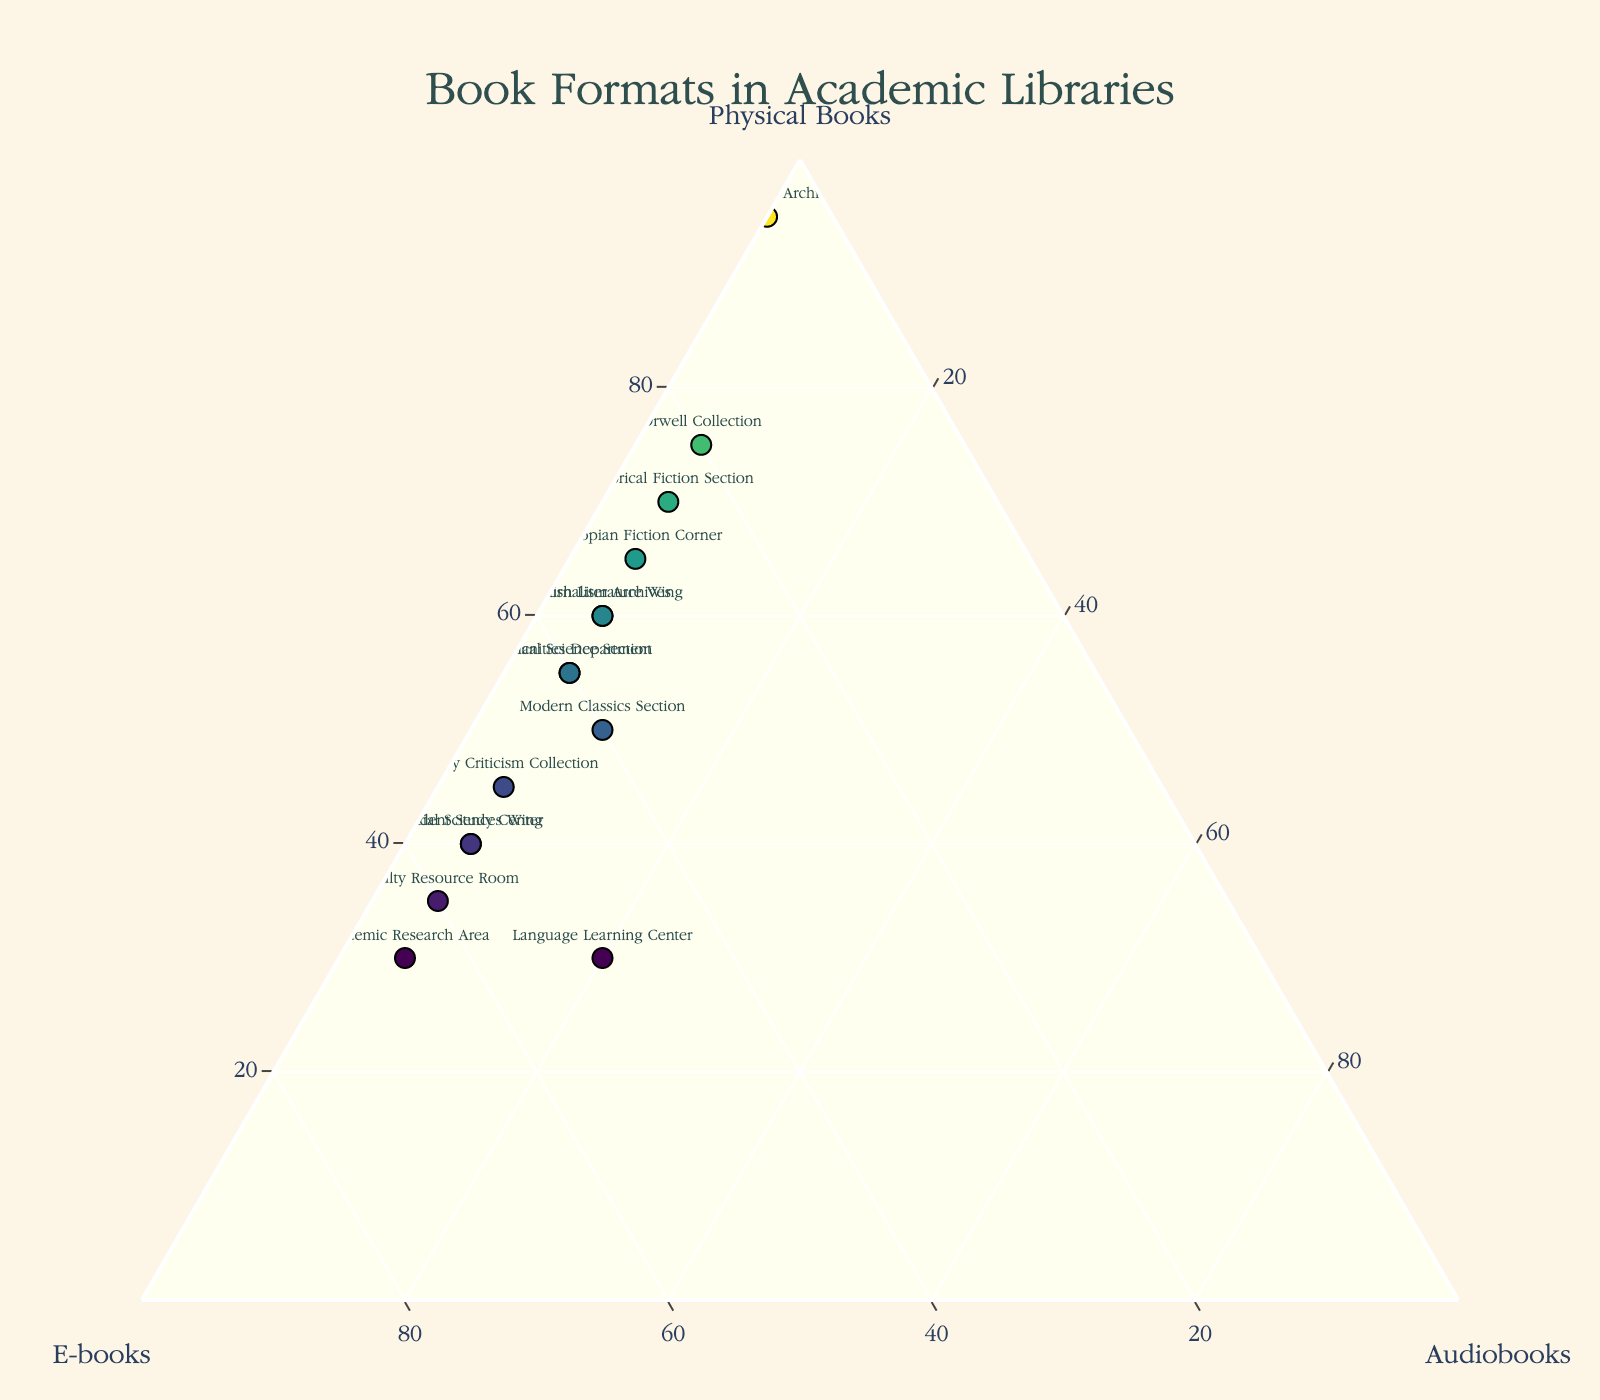How many libraries have at least 60% physical books? In the ternary plot, locate the data points where the 'Physical Books' value is 60 or higher. These points represent the libraries with at least 60% physical books.
Answer: 6 What is the sum of percentages for e-books and audiobooks in the Orwell Collection? Find the Orwell Collection on the plot and add its e-books (20) and audiobooks (5) percentages.
Answer: 25 Which library has the highest percentage of physical books? Identify the data point positioned closest to the 'Physical Books' vertex. Here, the 'Rare Books Archive' has 95% physical books.
Answer: Rare Books Archive How does the Humanities Department compare to the Social Sciences Wing in terms of e-books and audiobooks combined? Locate the two libraries on the plot and add the e-books and audiobooks percentages: Humanities Department (40 + 5 = 45) and Social Sciences Wing (55 + 5 = 60). The Social Sciences Wing has a higher combined percentage.
Answer: Social Sciences Wing Which libraries have an equal distribution of e-books and physical books? Find data points along the line where e-books and physical books percentages are the same. The parity means the e-books and physical books values should be visually equal or nearly equal. No libraries have exactly equal values in this dataset.
Answer: None Are there any libraries that have 0% audiobooks? Identify data points situated directly on the 'Physical Books' and 'E-books' axis lines. This indicates 0% audiobooks presence. The 'Rare Books Archive' is the relevant entry.
Answer: Rare Books Archive Which library has the highest percentage of e-books? Identify the data point closest to the 'E-books' vertex. This is the 'Academic Research Area' with 65% e-books.
Answer: Academic Research Area What is the median value of physical books across all libraries? Arrange the percentages of physical books in ascending order and find the middle value. Since there are 15 data points, the median will be the 8th value. Ordered: 30, 30, 30, 35, 40, 40, 40, 45, 50, 55, 55, 55, 60, 60, 65, 70, 75, 95. The median (8th value) is 45.
Answer: 45 